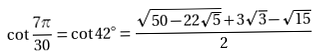Convert formula to latex. <formula><loc_0><loc_0><loc_500><loc_500>\cot { \frac { 7 \pi } { 3 0 } } = \cot 4 2 ^ { \circ } = { \frac { { \sqrt { 5 0 - 2 2 { \sqrt { 5 } } } } + 3 { \sqrt { 3 } } - { \sqrt { 1 5 } } } { 2 } }</formula> 